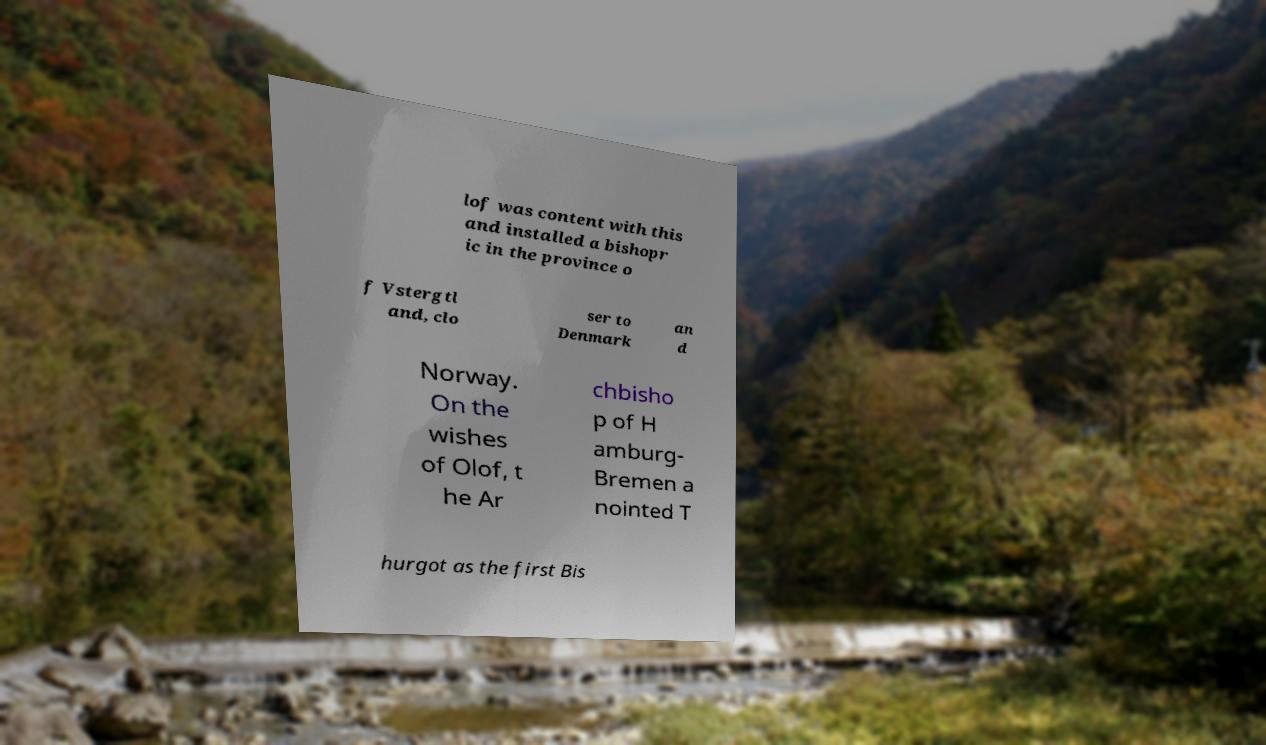Please identify and transcribe the text found in this image. lof was content with this and installed a bishopr ic in the province o f Vstergtl and, clo ser to Denmark an d Norway. On the wishes of Olof, t he Ar chbisho p of H amburg- Bremen a nointed T hurgot as the first Bis 